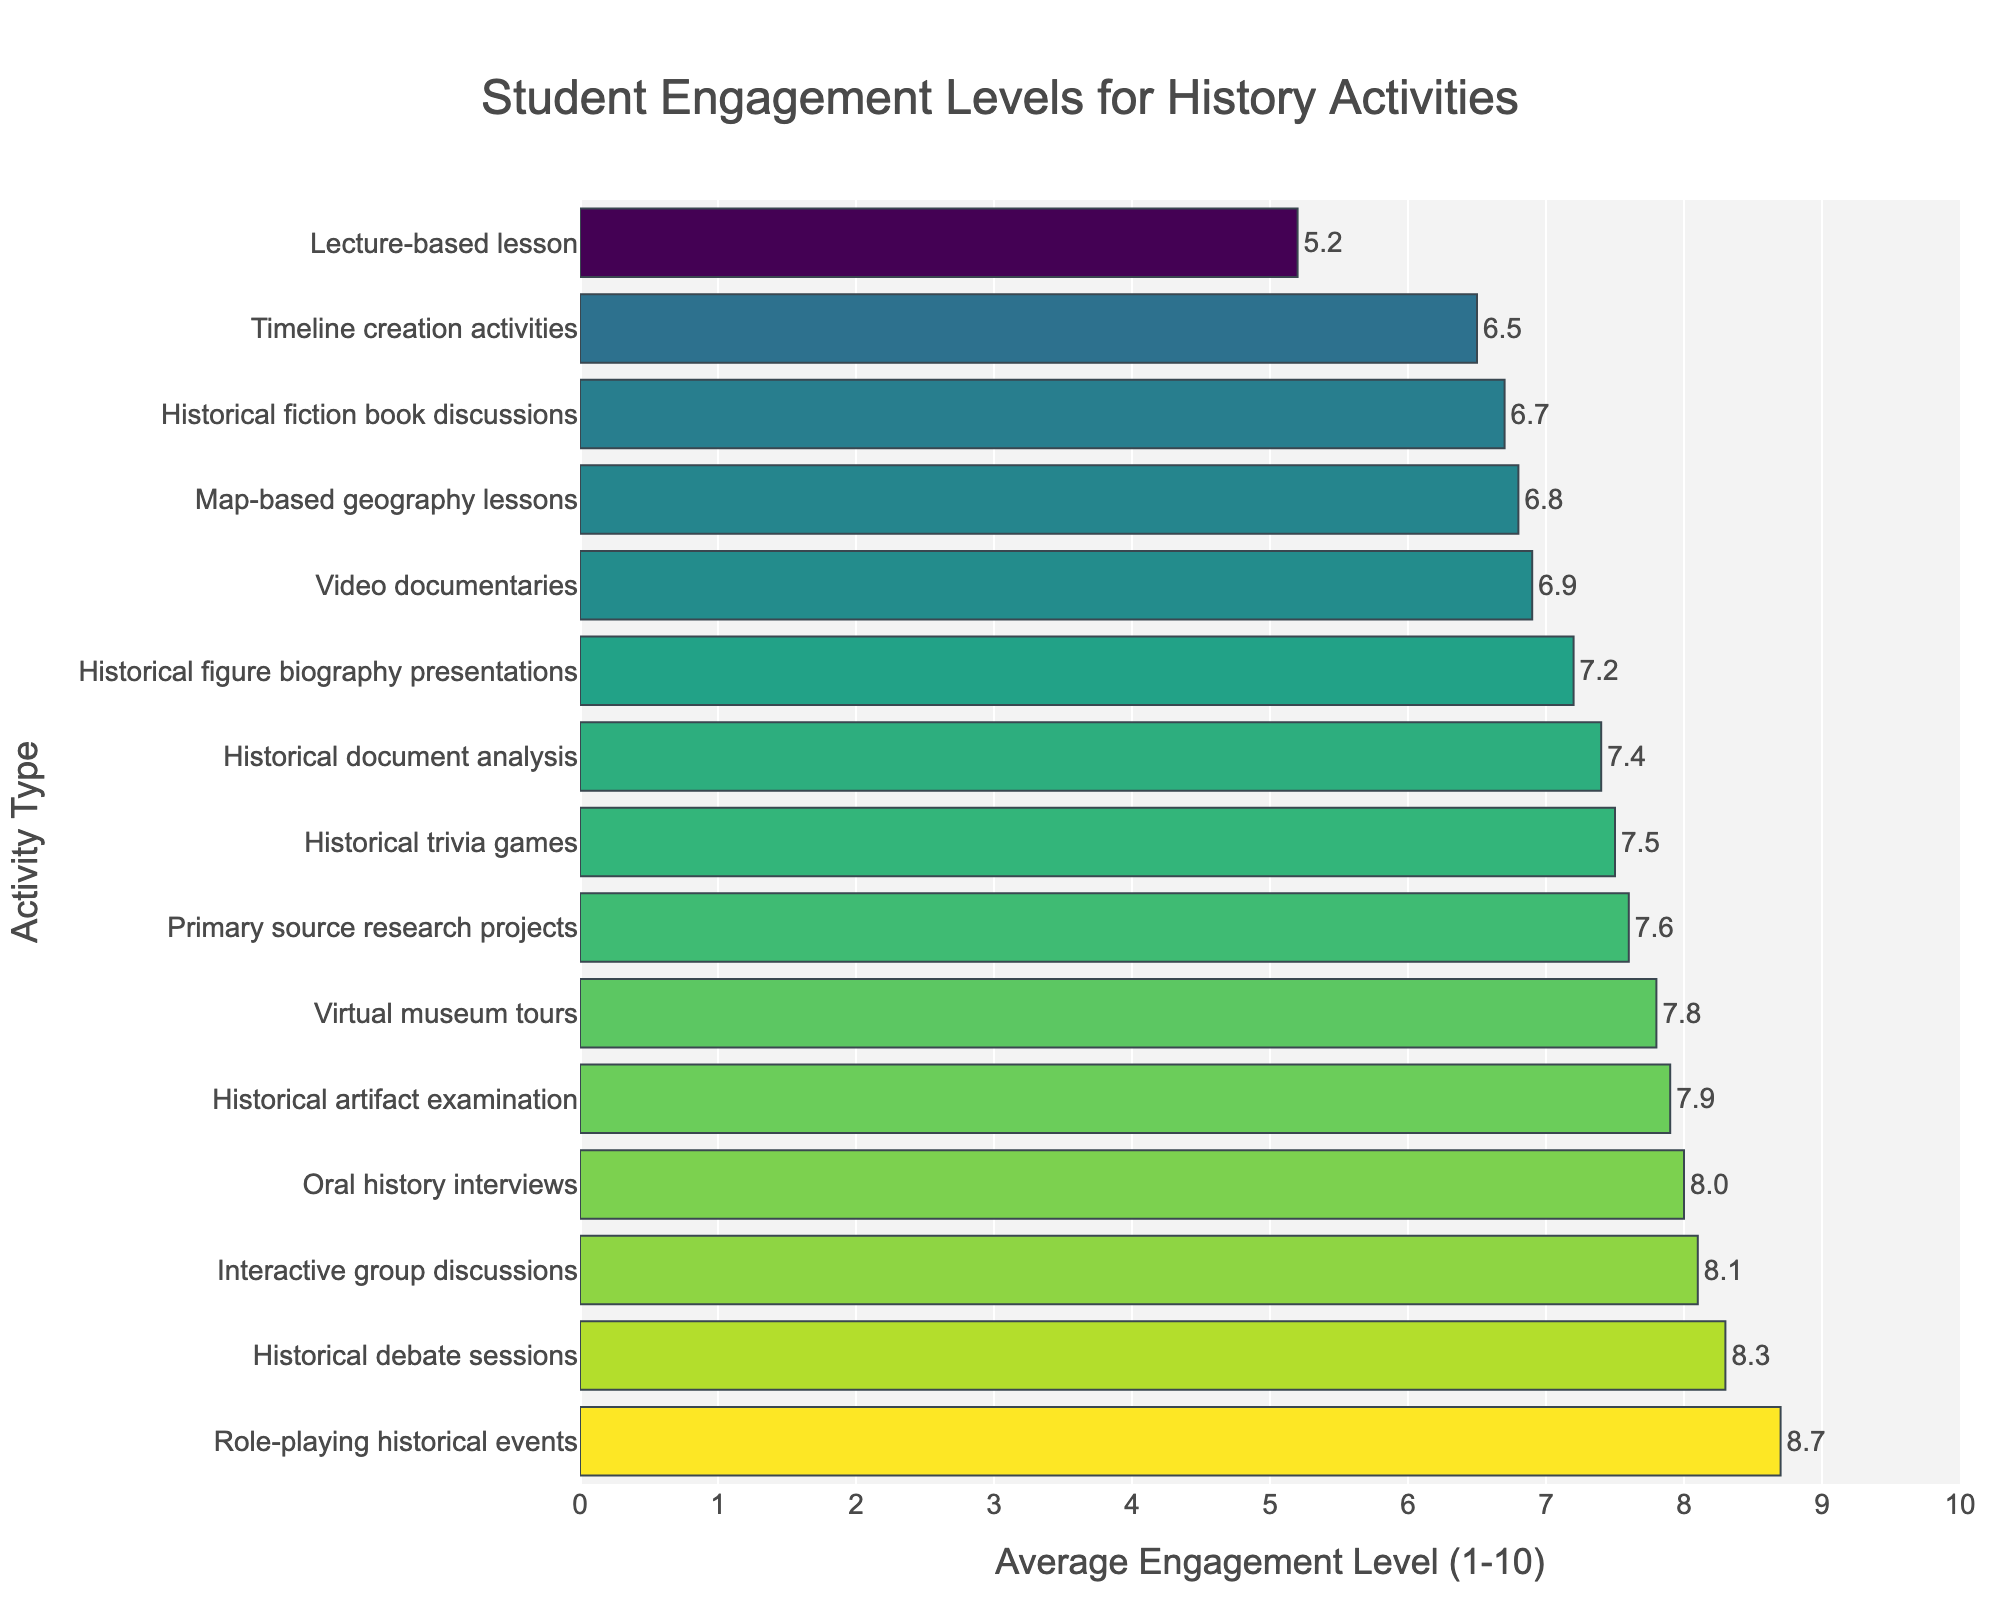what type of lesson has the highest average student engagement level? The highest average student engagement level is indicated by the tallest bar. Look for the tallest bar on the chart, which corresponds to "Role-playing historical events" with an engagement level of 8.7.
Answer: Role-playing historical events Which two activities have the closest average engagement levels? To find this, look at the bars that have similar lengths. "Primary source research projects" and "Historical document analysis" have engagement levels of 7.6 and 7.4, respectively.
Answer: Primary source research projects and Historical document analysis What is the difference between the engagement levels of Lecture-based lessons and Historical debate sessions? Look for the bars related to these activities and subtract the shorter bar's value from the taller bar's value. The engagement levels are 5.2 for Lecture-based lessons and 8.3 for Historical debate sessions. So, the difference is 8.3 - 5.2 = 3.1.
Answer: 3.1 Which activity has a higher engagement level, Oral history interviews or Historical artifact examination? Compare the lengths of the bars for these activities. Oral history interviews have an engagement level of 8.0, while Historical artifact examination has 7.9.
Answer: Oral history interviews How many activities have an engagement level above 7.0? Count the bars that extend beyond the 7.0 mark on the x-axis. There are 10 such activities.
Answer: 10 What is the average engagement level of Interactive group discussions, Video documentaries, and Historical trivia games? Sum the engagement levels of these three activities and then divide by 3. The engagement levels are 8.1, 6.9, and 7.5, respectively. So, (8.1 + 6.9 + 7.5) / 3 = 22.5 / 3 = 7.5.
Answer: 7.5 Which activity type has a lower average engagement level, Timeline creation activities or Historical fiction book discussions? Compare the bars for these activities. Timeline creation activities have an engagement level of 6.5, while Historical fiction book discussions have 6.7.
Answer: Timeline creation activities Rank the top three activities with the highest engagement levels. Identify the three tallest bars on the chart. The activities and their engagement levels are: 1) Role-playing historical events (8.7), 2) Historical debate sessions (8.3), and 3) Interactive group discussions (8.1).
Answer: Role-playing historical events, Historical debate sessions, Interactive group discussions 